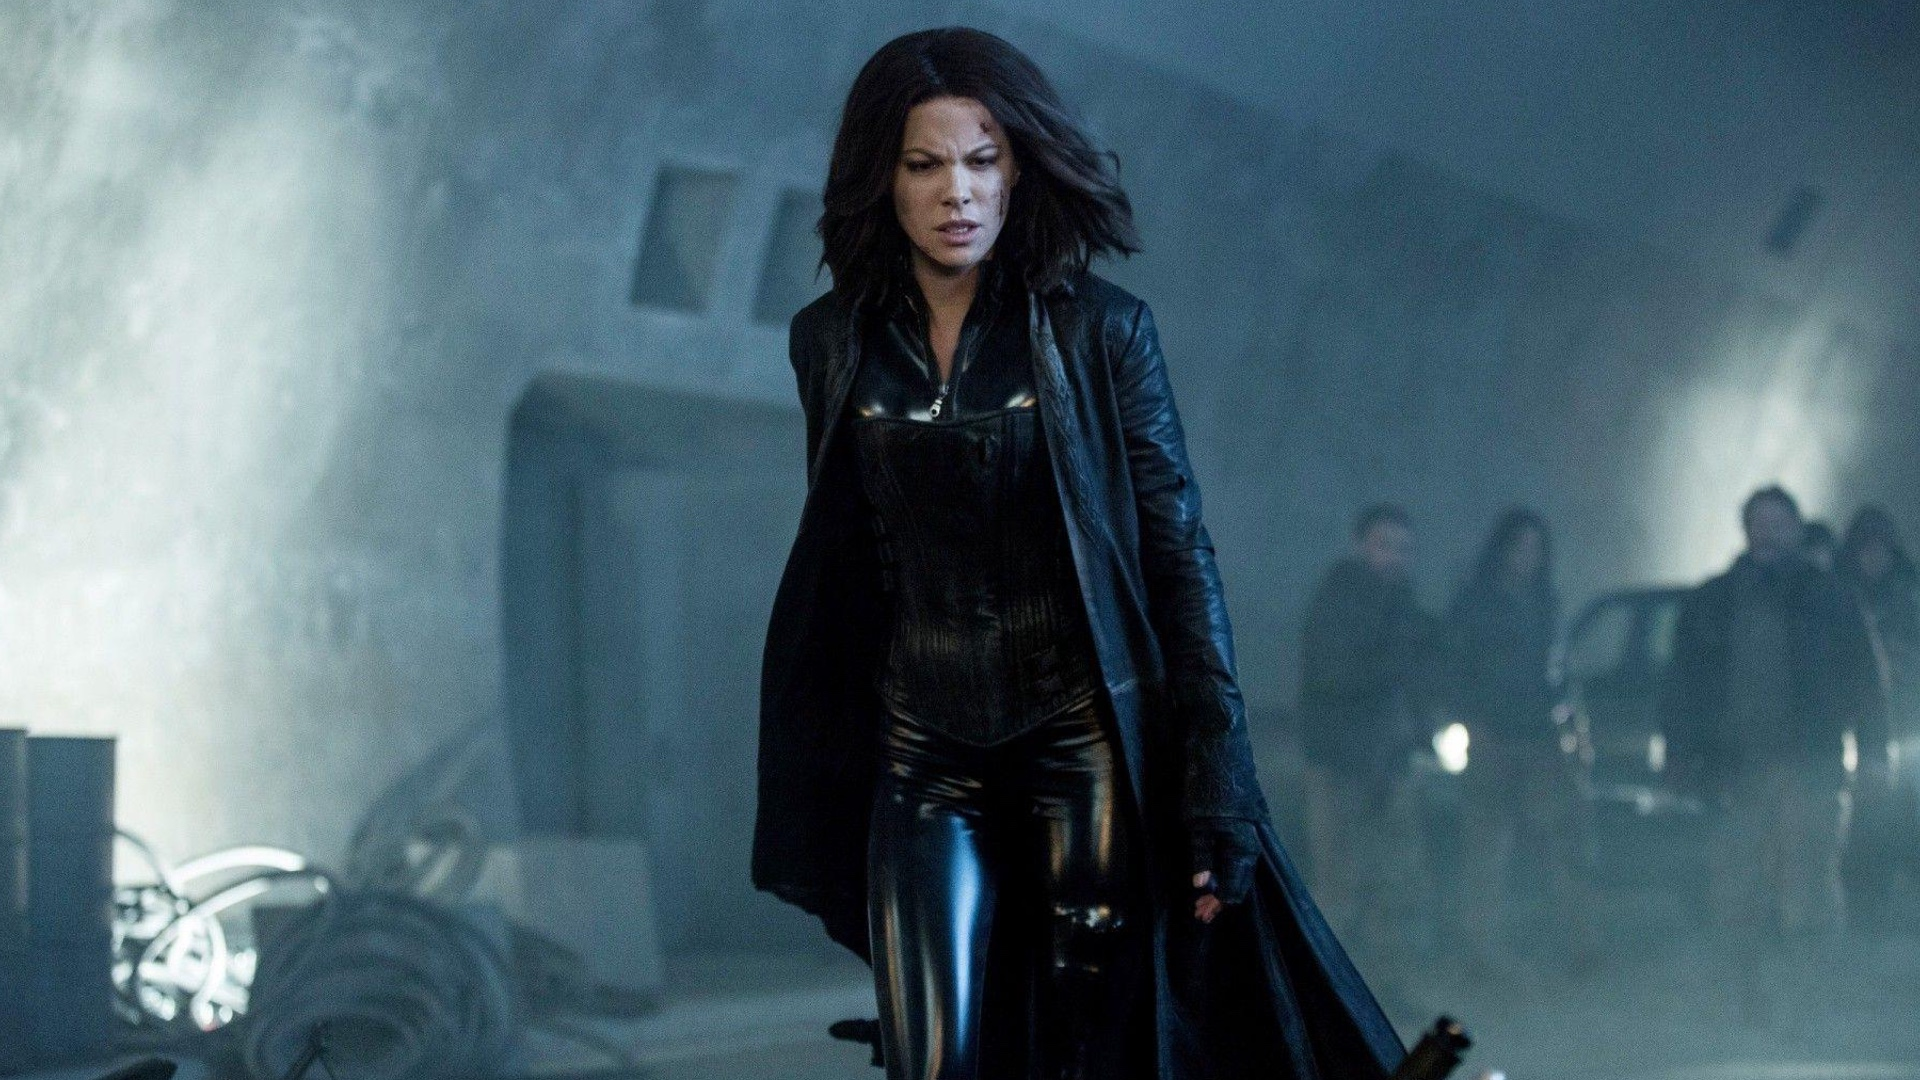What are the key elements in this picture? In the image, actress Kate Beckinsale is seen embodying her character, Selene, from the Underworld film series. She is captured mid-stride, advancing towards the camera with a resolute expression that speaks volumes of her character's determination and strength. Beckinsale's attire is a distinctive black leather ensemble complete with a long coat and high boots, a signature look for her character Selene. The backdrop is an industrial setting shrouded in fog, with a few indistinct figures and objects scattered in the distance. The overall color palette of the image is dark and moody, complementing the gothic aesthetic of the Underworld series. 